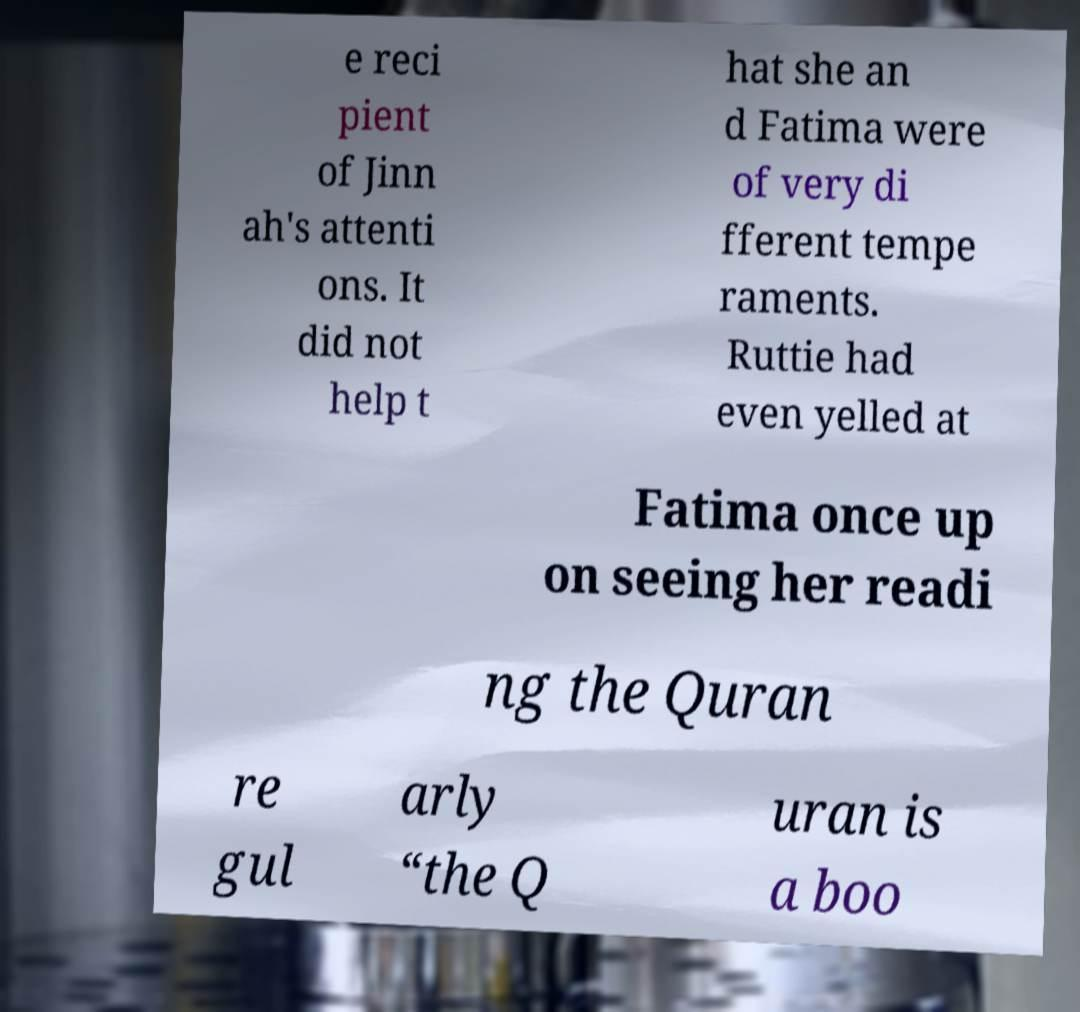Can you read and provide the text displayed in the image?This photo seems to have some interesting text. Can you extract and type it out for me? e reci pient of Jinn ah's attenti ons. It did not help t hat she an d Fatima were of very di fferent tempe raments. Ruttie had even yelled at Fatima once up on seeing her readi ng the Quran re gul arly “the Q uran is a boo 